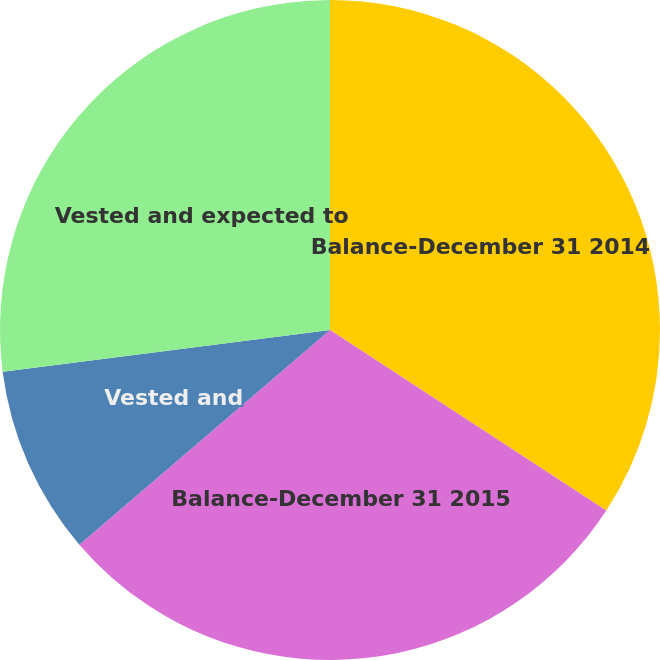Convert chart. <chart><loc_0><loc_0><loc_500><loc_500><pie_chart><fcel>Balance-December 31 2014<fcel>Balance-December 31 2015<fcel>Vested and<fcel>Vested and expected to<nl><fcel>34.21%<fcel>29.52%<fcel>9.25%<fcel>27.02%<nl></chart> 